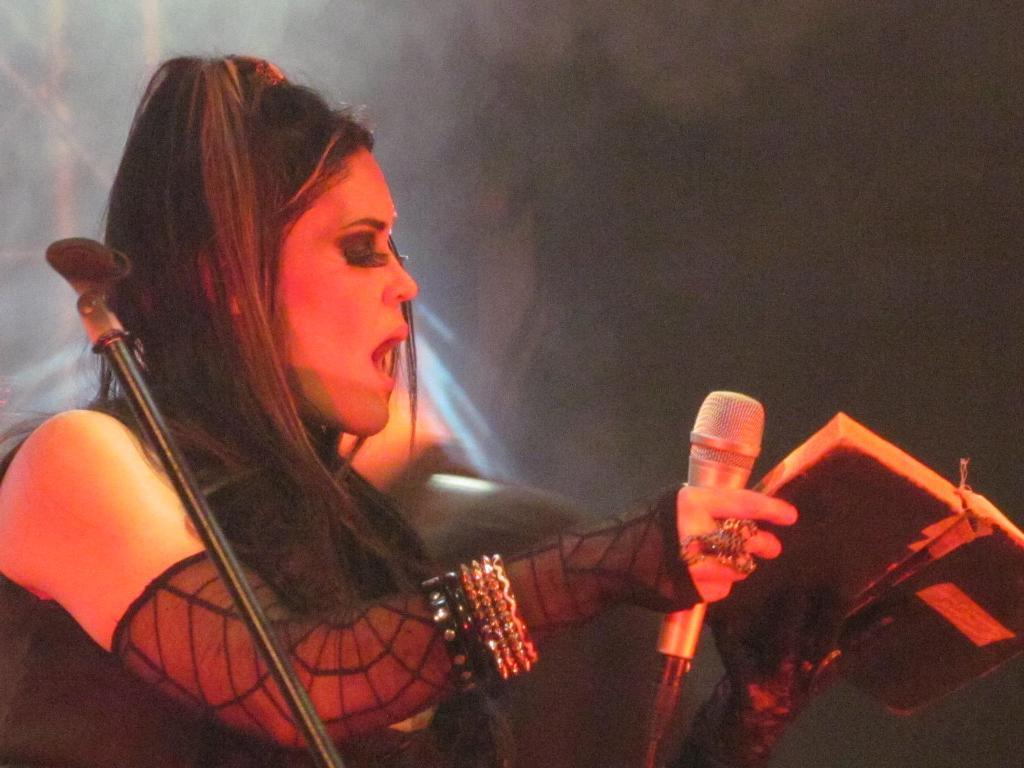What is the woman in the image holding? The woman is holding a book and a microphone. What might the woman be doing with the microphone? The woman might be using the microphone for speaking or presenting. What type of bun is the woman wearing in the image? There is no bun visible on the woman's head in the image. 